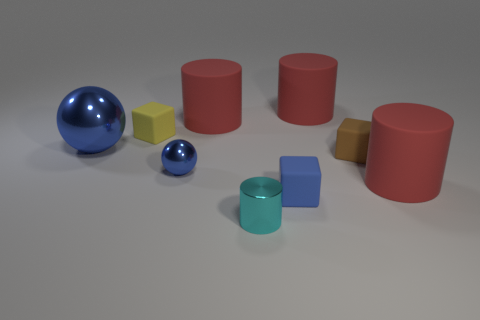Subtract all cyan cubes. How many red cylinders are left? 3 Add 1 tiny red rubber balls. How many objects exist? 10 Subtract all balls. How many objects are left? 7 Subtract all tiny blue cubes. Subtract all cyan objects. How many objects are left? 7 Add 5 large blue spheres. How many large blue spheres are left? 6 Add 8 tiny brown matte blocks. How many tiny brown matte blocks exist? 9 Subtract 0 purple spheres. How many objects are left? 9 